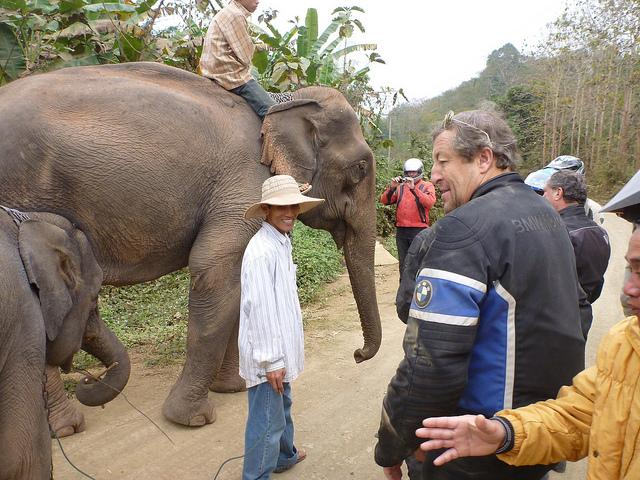Which of these men is most likely from a different country?

Choices:
A) plaid shirt
B) bmw jacket
C) yellow shirt
D) striped shirt bmw jacket 